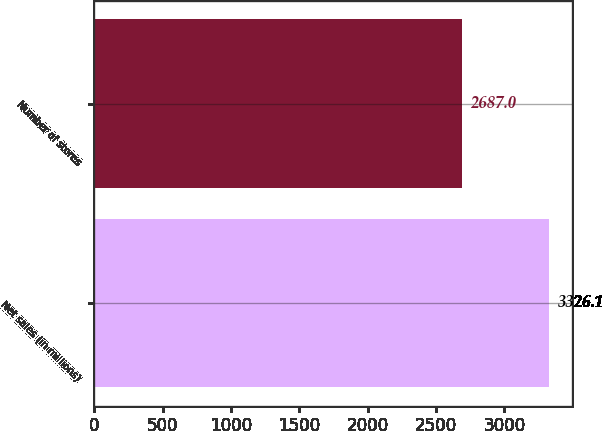Convert chart to OTSL. <chart><loc_0><loc_0><loc_500><loc_500><bar_chart><fcel>Net sales (in millions)<fcel>Number of stores<nl><fcel>3326.1<fcel>2687<nl></chart> 